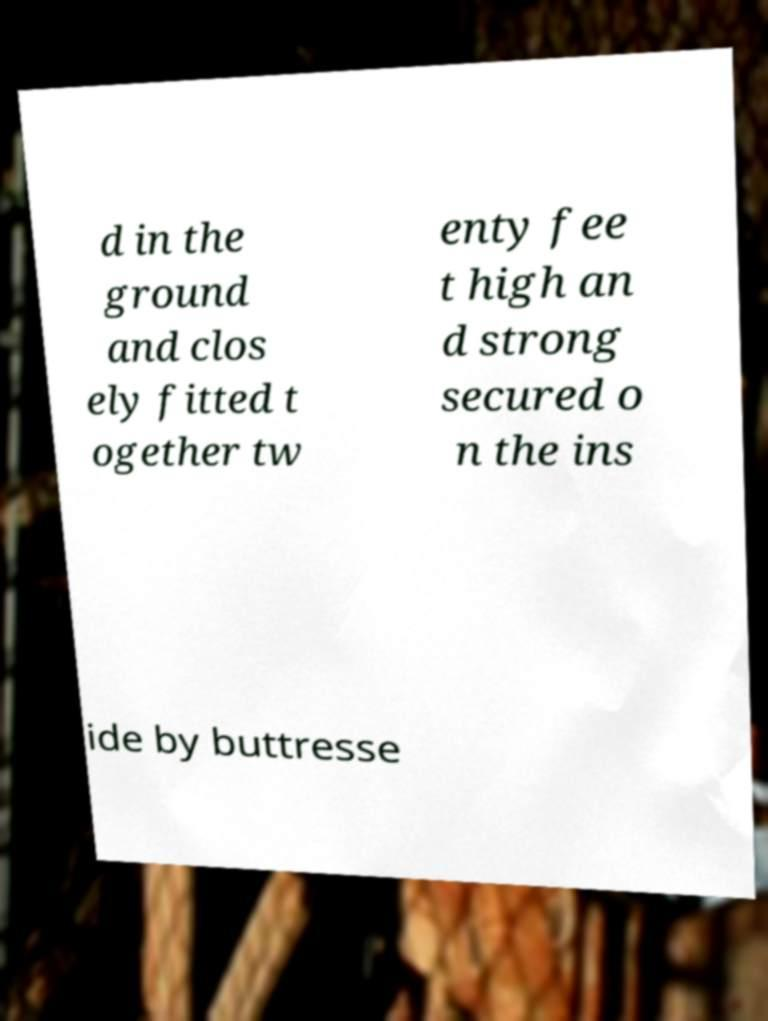For documentation purposes, I need the text within this image transcribed. Could you provide that? d in the ground and clos ely fitted t ogether tw enty fee t high an d strong secured o n the ins ide by buttresse 